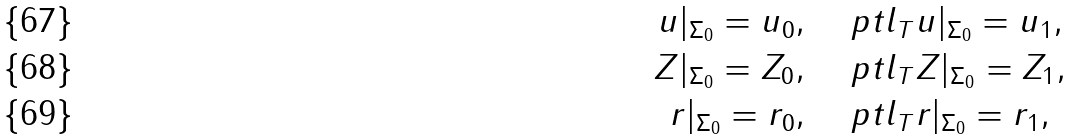Convert formula to latex. <formula><loc_0><loc_0><loc_500><loc_500>u | _ { \Sigma _ { 0 } } = u _ { 0 } , & \quad \ p t l _ { T } u | _ { \Sigma _ { 0 } } = u _ { 1 } , \\ Z | _ { \Sigma _ { 0 } } = Z _ { 0 } , & \quad \ p t l _ { T } Z | _ { \Sigma _ { 0 } } = Z _ { 1 } , \\ r | _ { \Sigma _ { 0 } } = r _ { 0 } , & \quad \ p t l _ { T } r | _ { \Sigma _ { 0 } } = r _ { 1 } ,</formula> 